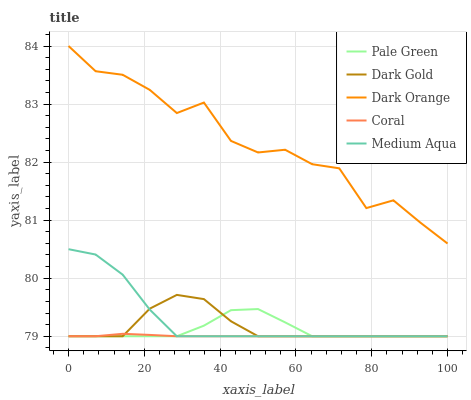Does Coral have the minimum area under the curve?
Answer yes or no. Yes. Does Pale Green have the minimum area under the curve?
Answer yes or no. No. Does Pale Green have the maximum area under the curve?
Answer yes or no. No. Is Coral the smoothest?
Answer yes or no. Yes. Is Dark Orange the roughest?
Answer yes or no. Yes. Is Pale Green the smoothest?
Answer yes or no. No. Is Pale Green the roughest?
Answer yes or no. No. Does Pale Green have the highest value?
Answer yes or no. No. Is Coral less than Dark Orange?
Answer yes or no. Yes. Is Dark Orange greater than Pale Green?
Answer yes or no. Yes. Does Coral intersect Dark Orange?
Answer yes or no. No. 